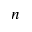<formula> <loc_0><loc_0><loc_500><loc_500>n</formula> 